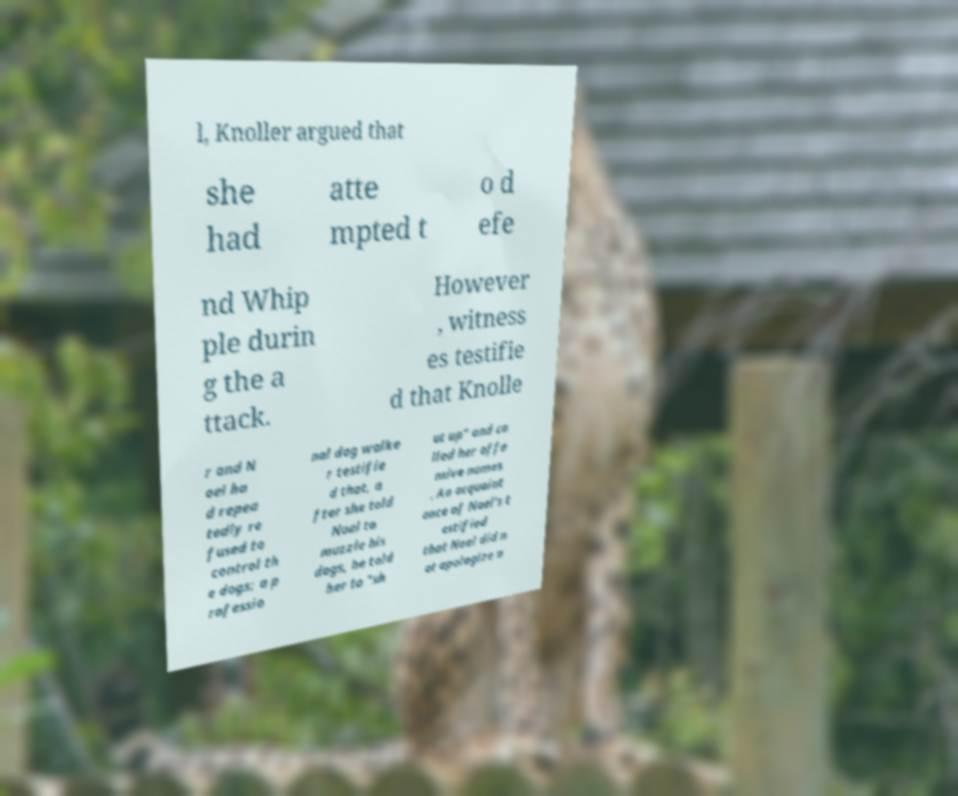Could you assist in decoding the text presented in this image and type it out clearly? l, Knoller argued that she had atte mpted t o d efe nd Whip ple durin g the a ttack. However , witness es testifie d that Knolle r and N oel ha d repea tedly re fused to control th e dogs; a p rofessio nal dog walke r testifie d that, a fter she told Noel to muzzle his dogs, he told her to "sh ut up" and ca lled her offe nsive names . An acquaint ance of Noel's t estified that Noel did n ot apologize a 